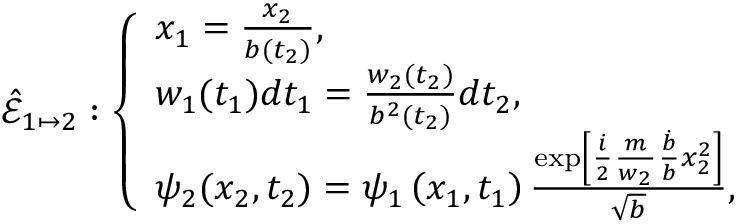Convert formula to latex. <formula><loc_0><loc_0><loc_500><loc_500>\hat { \mathcal { E } } _ { 1 \mapsto 2 } \colon \left \{ \begin{array} { l l } { x _ { 1 } = \frac { x _ { 2 } } { b ( t _ { 2 } ) } , } \\ { w _ { 1 } ( t _ { 1 } ) d t _ { 1 } = \frac { w _ { 2 } ( t _ { 2 } ) } { b ^ { 2 } ( t _ { 2 } ) } d t _ { 2 } , } \\ { \psi _ { 2 } ( x _ { 2 } , t _ { 2 } ) = \psi _ { 1 } \left ( x _ { 1 } , t _ { 1 } \right ) \frac { \exp \left [ { \frac { i } { 2 } \frac { m } { w _ { 2 } } \frac { \dot { b } } { b } x _ { 2 } ^ { 2 } } \right ] } { \sqrt { b } } , } \end{array}</formula> 